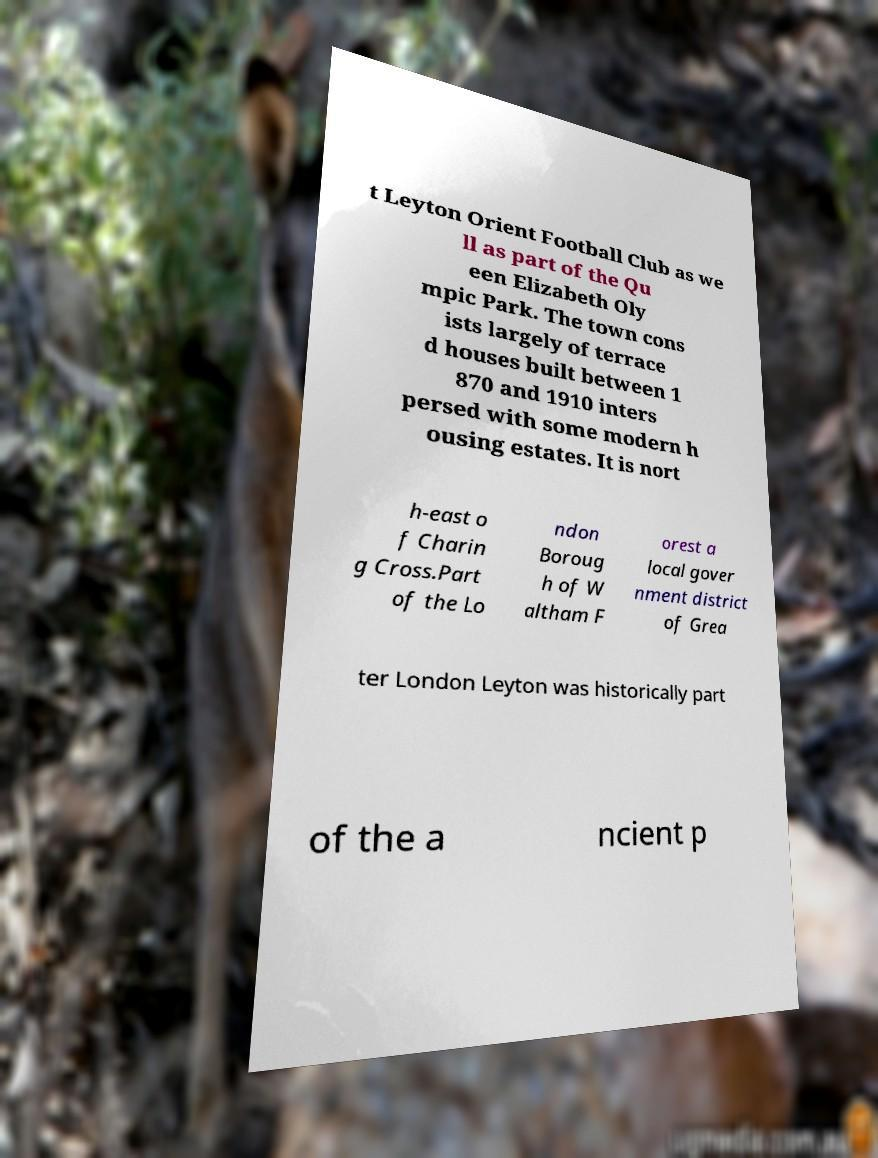I need the written content from this picture converted into text. Can you do that? t Leyton Orient Football Club as we ll as part of the Qu een Elizabeth Oly mpic Park. The town cons ists largely of terrace d houses built between 1 870 and 1910 inters persed with some modern h ousing estates. It is nort h-east o f Charin g Cross.Part of the Lo ndon Boroug h of W altham F orest a local gover nment district of Grea ter London Leyton was historically part of the a ncient p 